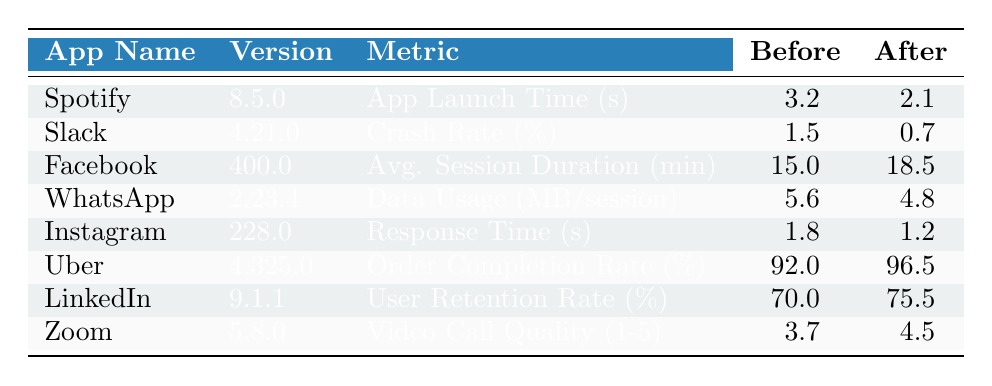What is the app launch time for Spotify before the update? The table indicates that for Spotify, the app launch time before the update was 3.2 seconds. This value is directly retrieved from the corresponding row for Spotify.
Answer: 3.2 seconds What was the percentage decrease in the crash rate for Slack after the update? Slack's crash rate before the update was 1.5%, and after the update, it dropped to 0.7%. The percentage decrease is calculated as (1.5 - 0.7) / 1.5 * 100 = 53.33%.
Answer: 53.33% Did the average session duration for Facebook increase after the update? The average session duration for Facebook increased from 15.0 minutes before the update to 18.5 minutes after the update. This indicates a clear increase in this metric.
Answer: Yes What is the average order completion rate for Uber before and after the update? For Uber, the order completion rate before the update was 92.0%, and after the update, it increased to 96.5%. The average of these two is (92.0 + 96.5) / 2 = 94.25%.
Answer: 94.25% Which app had the fastest response time after the update? After comparing the response times after the update, Instagram had the lowest response time at 1.2 seconds, which is less than any other app's response time listed in the table.
Answer: Instagram What is the percentage of user retention rate increase for LinkedIn? LinkedIn's user retention rate improved from 70.0% before the update to 75.5% after the update. The percentage increase is (75.5 - 70.0) / 70.0 * 100 = 7.86%.
Answer: 7.86% Which application had the highest improvement in video call quality rating? Zoom increased its video call quality rating from 3.7 to 4.5. The difference of 4.5 - 3.7 = 0.8 signifies the highest improvement among the listed apps.
Answer: Zoom Is the data usage per session for WhatsApp lower after the update? The data usage for WhatsApp decreased from 5.6 MB per session before the update to 4.8 MB per session after the update, confirming a reduction in data usage.
Answer: Yes What is the total improvement in app launch time for Spotify compared to its previous version? The improvement in app launch time is calculated as 3.2 seconds (before) - 2.1 seconds (after) = 1.1 seconds improvement after the update.
Answer: 1.1 seconds 